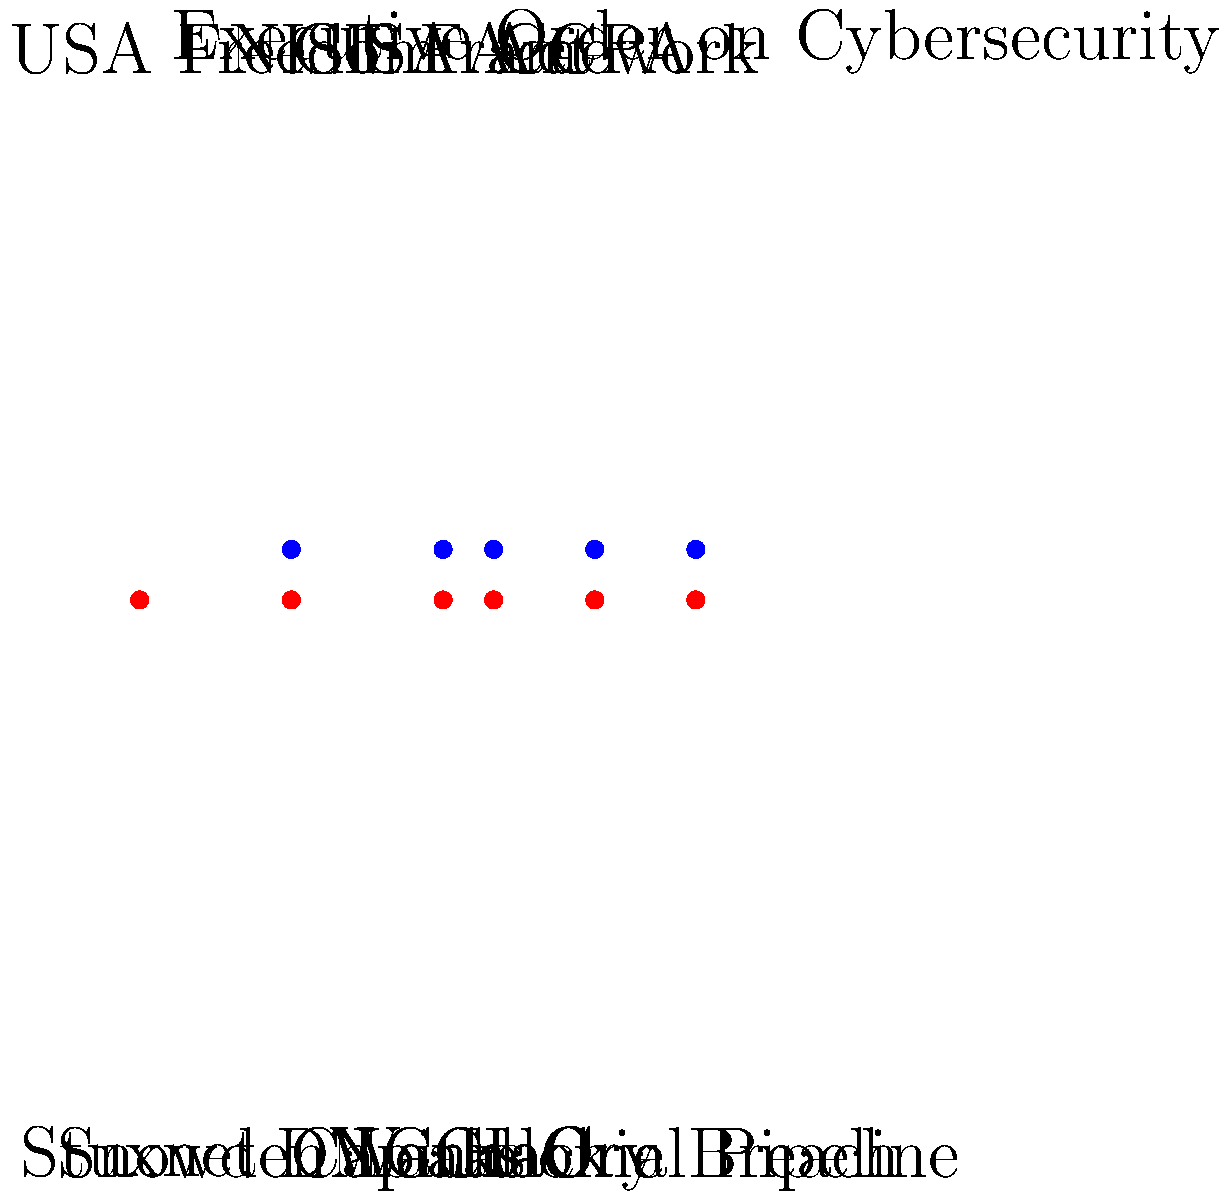Based on the timeline diagram, which cybersecurity incident likely had the most immediate and significant impact on U.S. policy, as evidenced by the proximity of a major policy response? To answer this question, we need to analyze the timeline diagram and look for the closest connection between a cybersecurity incident and a subsequent policy response. Let's examine the incidents and policies chronologically:

1. 2010: Stuxnet incident - No immediate policy response shown.
2. 2013: Snowden Leaks - Followed by the USA Freedom Act in the same year.
3. 2016: DNC Hack - Followed by the CISA Act in the same year.
4. 2017: WannaCry - Followed by the NIST Framework in the same year.
5. 2019: Capital One Breach - Followed by CCPA in the same year.
6. 2021: Colonial Pipeline - Followed by Executive Order on Cybersecurity in the same year.

The Snowden Leaks in 2013 are the earliest incident on the timeline with an immediate policy response (USA Freedom Act) in the same year. This quick legislative action suggests that the Snowden Leaks had a significant and immediate impact on U.S. policy.

While other incidents also have policy responses in the same year, the Snowden Leaks stand out as a pivotal moment in cybersecurity and privacy discussions, leading to substantial changes in U.S. surveillance laws and practices.
Answer: Snowden Leaks 